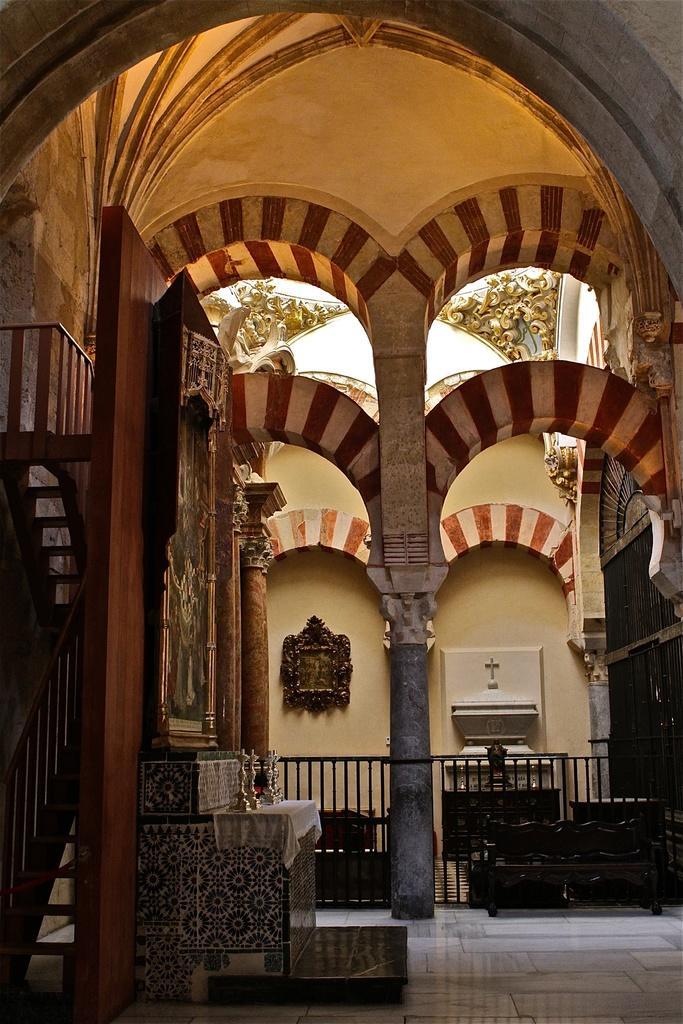Can you describe this image briefly? In this image on the left side there is a staircase and some boards and some statues, pillars, railing and at the bottom there is a floor. In the background there is a wall, and at the top there is ceiling. 